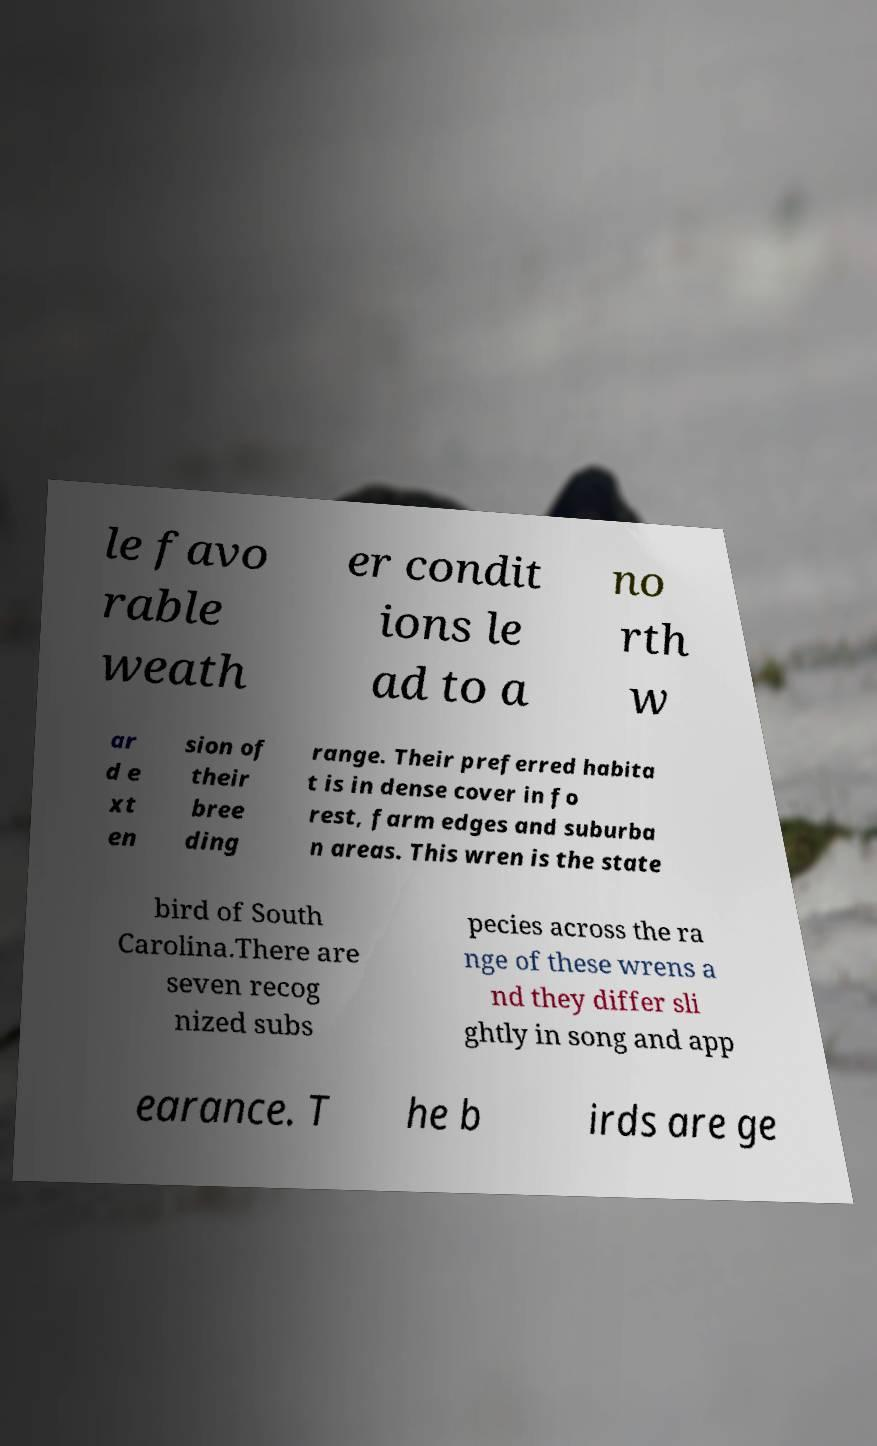For documentation purposes, I need the text within this image transcribed. Could you provide that? le favo rable weath er condit ions le ad to a no rth w ar d e xt en sion of their bree ding range. Their preferred habita t is in dense cover in fo rest, farm edges and suburba n areas. This wren is the state bird of South Carolina.There are seven recog nized subs pecies across the ra nge of these wrens a nd they differ sli ghtly in song and app earance. T he b irds are ge 